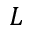Convert formula to latex. <formula><loc_0><loc_0><loc_500><loc_500>L</formula> 